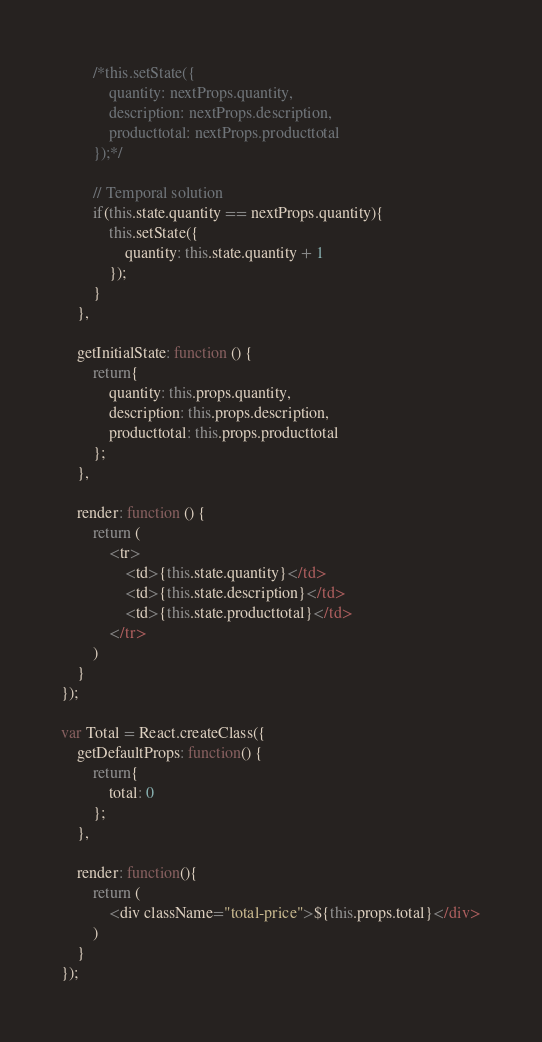<code> <loc_0><loc_0><loc_500><loc_500><_JavaScript_>        /*this.setState({
            quantity: nextProps.quantity,
            description: nextProps.description,
            producttotal: nextProps.producttotal
        });*/

        // Temporal solution
        if(this.state.quantity == nextProps.quantity){
            this.setState({
                quantity: this.state.quantity + 1
            });
        }
    },

    getInitialState: function () {
        return{
            quantity: this.props.quantity,
            description: this.props.description,
            producttotal: this.props.producttotal
        };
    },

    render: function () {
        return (
            <tr>
                <td>{this.state.quantity}</td>
                <td>{this.state.description}</td>
                <td>{this.state.producttotal}</td>
            </tr>
        )
    }
});

var Total = React.createClass({
    getDefaultProps: function() {
        return{
            total: 0
        };
    },

    render: function(){
        return (
            <div className="total-price">${this.props.total}</div>
        )
    }
});</code> 